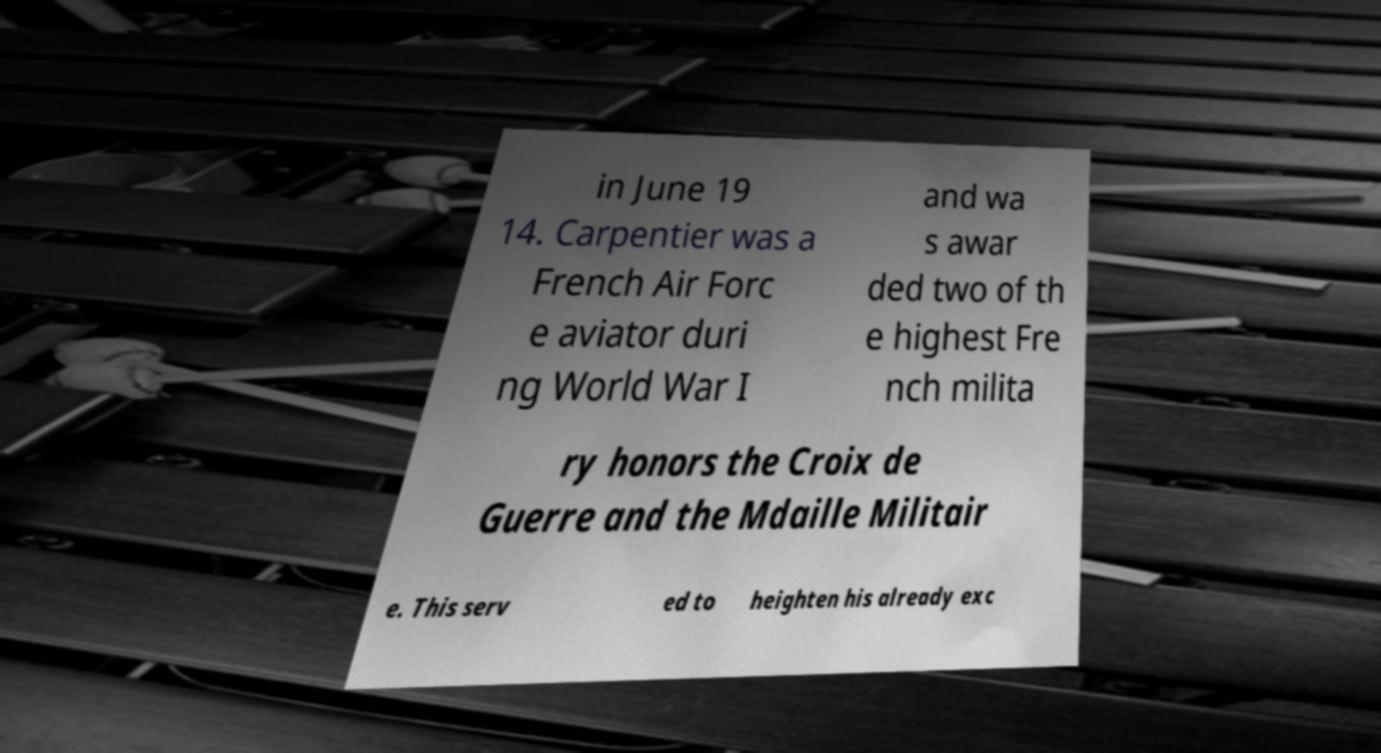What messages or text are displayed in this image? I need them in a readable, typed format. in June 19 14. Carpentier was a French Air Forc e aviator duri ng World War I and wa s awar ded two of th e highest Fre nch milita ry honors the Croix de Guerre and the Mdaille Militair e. This serv ed to heighten his already exc 